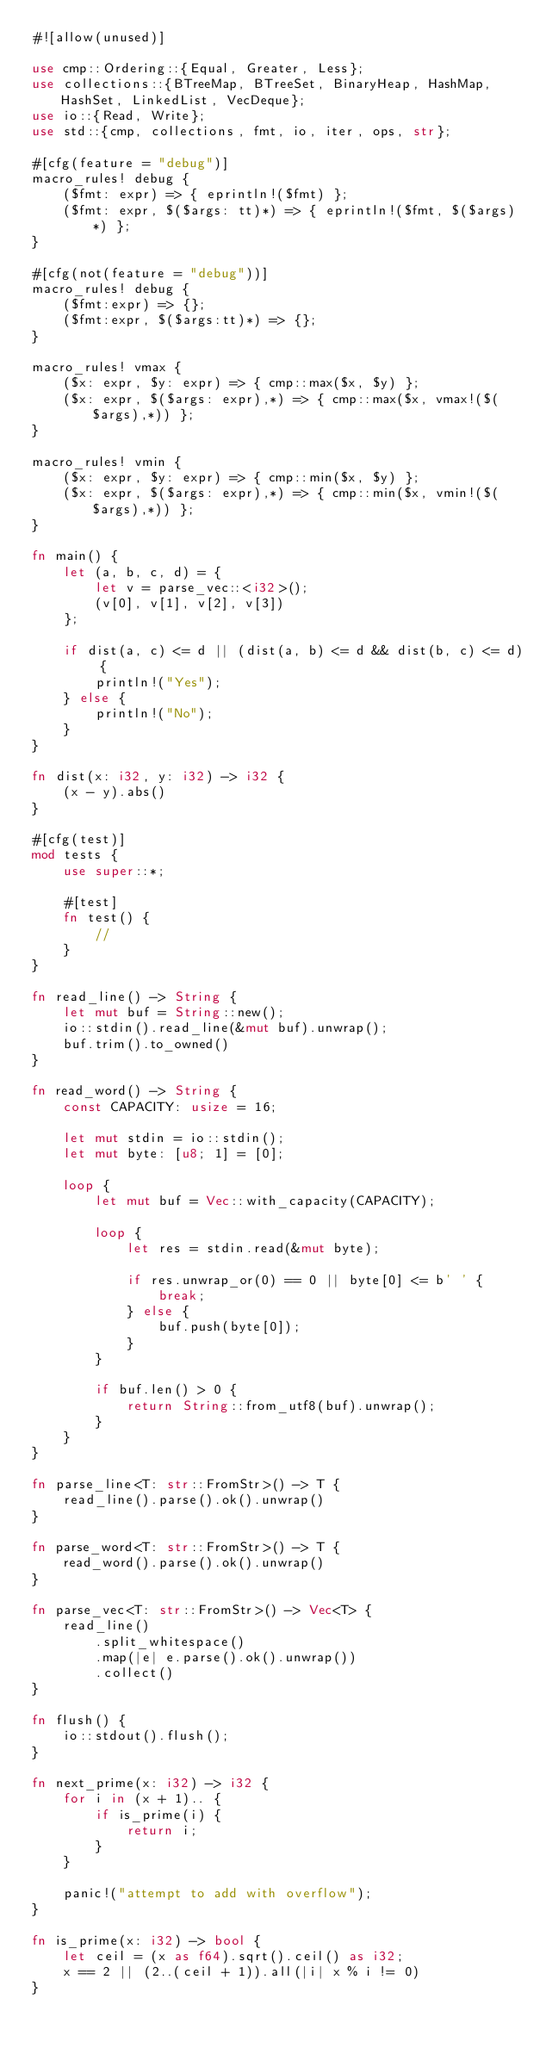Convert code to text. <code><loc_0><loc_0><loc_500><loc_500><_Rust_>#![allow(unused)]

use cmp::Ordering::{Equal, Greater, Less};
use collections::{BTreeMap, BTreeSet, BinaryHeap, HashMap, HashSet, LinkedList, VecDeque};
use io::{Read, Write};
use std::{cmp, collections, fmt, io, iter, ops, str};

#[cfg(feature = "debug")]
macro_rules! debug {
    ($fmt: expr) => { eprintln!($fmt) };
    ($fmt: expr, $($args: tt)*) => { eprintln!($fmt, $($args)*) };
}

#[cfg(not(feature = "debug"))]
macro_rules! debug {
    ($fmt:expr) => {};
    ($fmt:expr, $($args:tt)*) => {};
}

macro_rules! vmax {
    ($x: expr, $y: expr) => { cmp::max($x, $y) };
    ($x: expr, $($args: expr),*) => { cmp::max($x, vmax!($($args),*)) };
}

macro_rules! vmin {
    ($x: expr, $y: expr) => { cmp::min($x, $y) };
    ($x: expr, $($args: expr),*) => { cmp::min($x, vmin!($($args),*)) };
}

fn main() {
    let (a, b, c, d) = {
        let v = parse_vec::<i32>();
        (v[0], v[1], v[2], v[3])
    };

    if dist(a, c) <= d || (dist(a, b) <= d && dist(b, c) <= d) {
        println!("Yes");
    } else {
        println!("No");
    }
}

fn dist(x: i32, y: i32) -> i32 {
    (x - y).abs()
}

#[cfg(test)]
mod tests {
    use super::*;

    #[test]
    fn test() {
        //
    }
}

fn read_line() -> String {
    let mut buf = String::new();
    io::stdin().read_line(&mut buf).unwrap();
    buf.trim().to_owned()
}

fn read_word() -> String {
    const CAPACITY: usize = 16;

    let mut stdin = io::stdin();
    let mut byte: [u8; 1] = [0];

    loop {
        let mut buf = Vec::with_capacity(CAPACITY);

        loop {
            let res = stdin.read(&mut byte);

            if res.unwrap_or(0) == 0 || byte[0] <= b' ' {
                break;
            } else {
                buf.push(byte[0]);
            }
        }

        if buf.len() > 0 {
            return String::from_utf8(buf).unwrap();
        }
    }
}

fn parse_line<T: str::FromStr>() -> T {
    read_line().parse().ok().unwrap()
}

fn parse_word<T: str::FromStr>() -> T {
    read_word().parse().ok().unwrap()
}

fn parse_vec<T: str::FromStr>() -> Vec<T> {
    read_line()
        .split_whitespace()
        .map(|e| e.parse().ok().unwrap())
        .collect()
}

fn flush() {
    io::stdout().flush();
}

fn next_prime(x: i32) -> i32 {
    for i in (x + 1).. {
        if is_prime(i) {
            return i;
        }
    }

    panic!("attempt to add with overflow");
}

fn is_prime(x: i32) -> bool {
    let ceil = (x as f64).sqrt().ceil() as i32;
    x == 2 || (2..(ceil + 1)).all(|i| x % i != 0)
}
</code> 